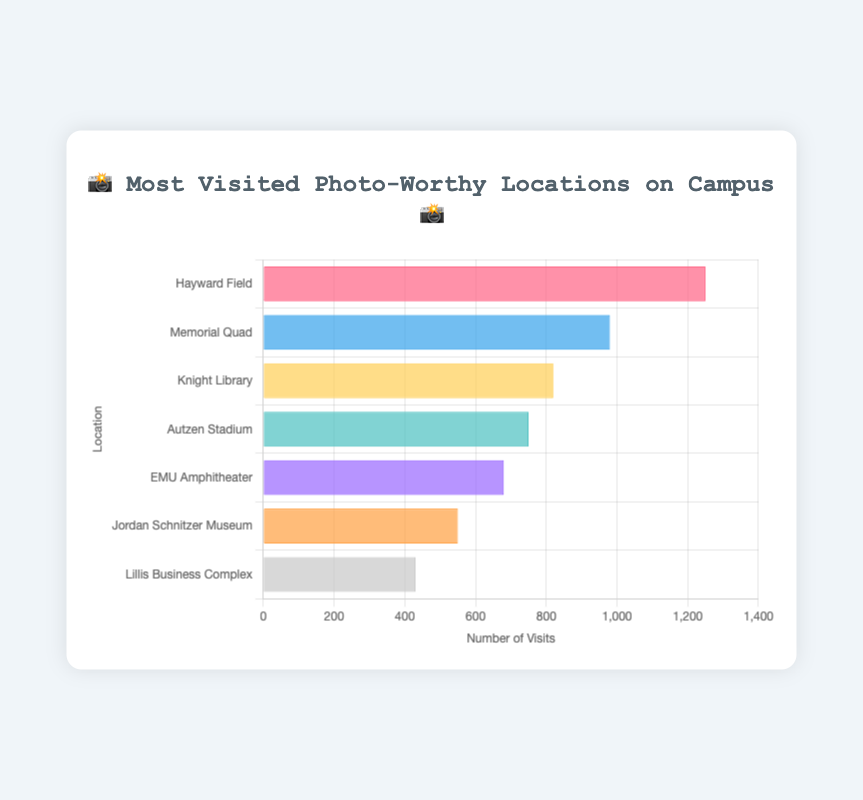Which location has the most visits? The bar labeled "Hayward Field" shows the highest value on the horizontal axis, indicating it has the most visits.
Answer: Hayward Field What is the least visited location? The shortest bar corresponds to the "Lillis Business Complex," indicating it has the least visits.
Answer: Lillis Business Complex How many visits does Autzen Stadium have? The bar next to the "🏈" emoji is labeled "Autzen Stadium" and reaches the horizontal value of 750.
Answer: 750 What is the sum of visits to Memorial Quad and Knight Library? Adding the visits of Memorial Quad (980) and Knight Library (820) gives 980 + 820.
Answer: 1800 Which location has more visits, EMU Amphitheater or Jordan Schnitzer Museum? Comparing the lengths of the bars, EMU Amphitheater (680) has more visits than Jordan Schnitzer Museum (550).
Answer: EMU Amphitheater Between Knight Library and Autzen Stadium, which one is visited more frequently? The bar for Knight Library (820) is longer than that for Autzen Stadium (750), indicating it is visited more frequently.
Answer: Knight Library What is the average number of visits across all locations? Summing all visits (1250 + 980 + 820 + 750 + 680 + 550 + 430) gives 5460. Dividing by 7 locations, the average is 5460/7.
Answer: 780 How many locations have more than 800 visits? Both Hayward Field (1250) and Memorial Quad (980) have more than 800 visits, so there are 2 locations.
Answer: 2 What is the combined number of visits for the top three most visited locations? Adding visits for Hayward Field (1250), Memorial Quad (980), and Knight Library (820) gives 1250 + 980 + 820.
Answer: 3050 Which location has fewer than 600 visits but more than 500? Jordan Schnitzer Museum has 550 visits, which falls between 500 and 600.
Answer: Jordan Schnitzer Museum 